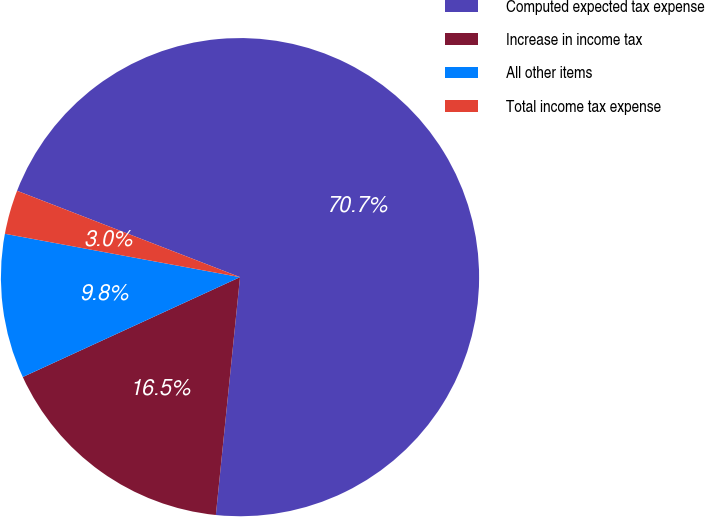Convert chart to OTSL. <chart><loc_0><loc_0><loc_500><loc_500><pie_chart><fcel>Computed expected tax expense<fcel>Increase in income tax<fcel>All other items<fcel>Total income tax expense<nl><fcel>70.73%<fcel>16.53%<fcel>9.76%<fcel>2.98%<nl></chart> 